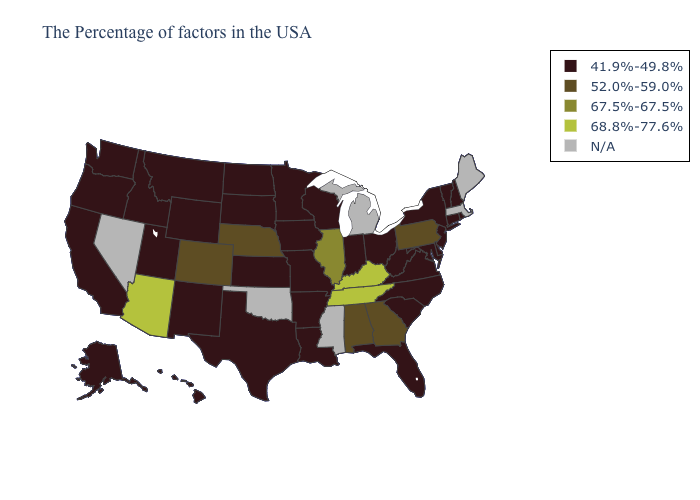Among the states that border Texas , which have the highest value?
Concise answer only. Louisiana, Arkansas, New Mexico. Does New Jersey have the lowest value in the Northeast?
Quick response, please. Yes. Does Wisconsin have the highest value in the MidWest?
Write a very short answer. No. Which states hav the highest value in the West?
Short answer required. Arizona. What is the value of Nevada?
Quick response, please. N/A. What is the highest value in states that border Minnesota?
Give a very brief answer. 41.9%-49.8%. Does Tennessee have the highest value in the USA?
Keep it brief. Yes. What is the highest value in the Northeast ?
Quick response, please. 52.0%-59.0%. Among the states that border Washington , which have the highest value?
Quick response, please. Idaho, Oregon. Does the first symbol in the legend represent the smallest category?
Write a very short answer. Yes. Name the states that have a value in the range 67.5%-67.5%?
Be succinct. Illinois. Name the states that have a value in the range 41.9%-49.8%?
Be succinct. Rhode Island, New Hampshire, Vermont, Connecticut, New York, New Jersey, Delaware, Maryland, Virginia, North Carolina, South Carolina, West Virginia, Ohio, Florida, Indiana, Wisconsin, Louisiana, Missouri, Arkansas, Minnesota, Iowa, Kansas, Texas, South Dakota, North Dakota, Wyoming, New Mexico, Utah, Montana, Idaho, California, Washington, Oregon, Alaska, Hawaii. What is the value of Michigan?
Concise answer only. N/A. 